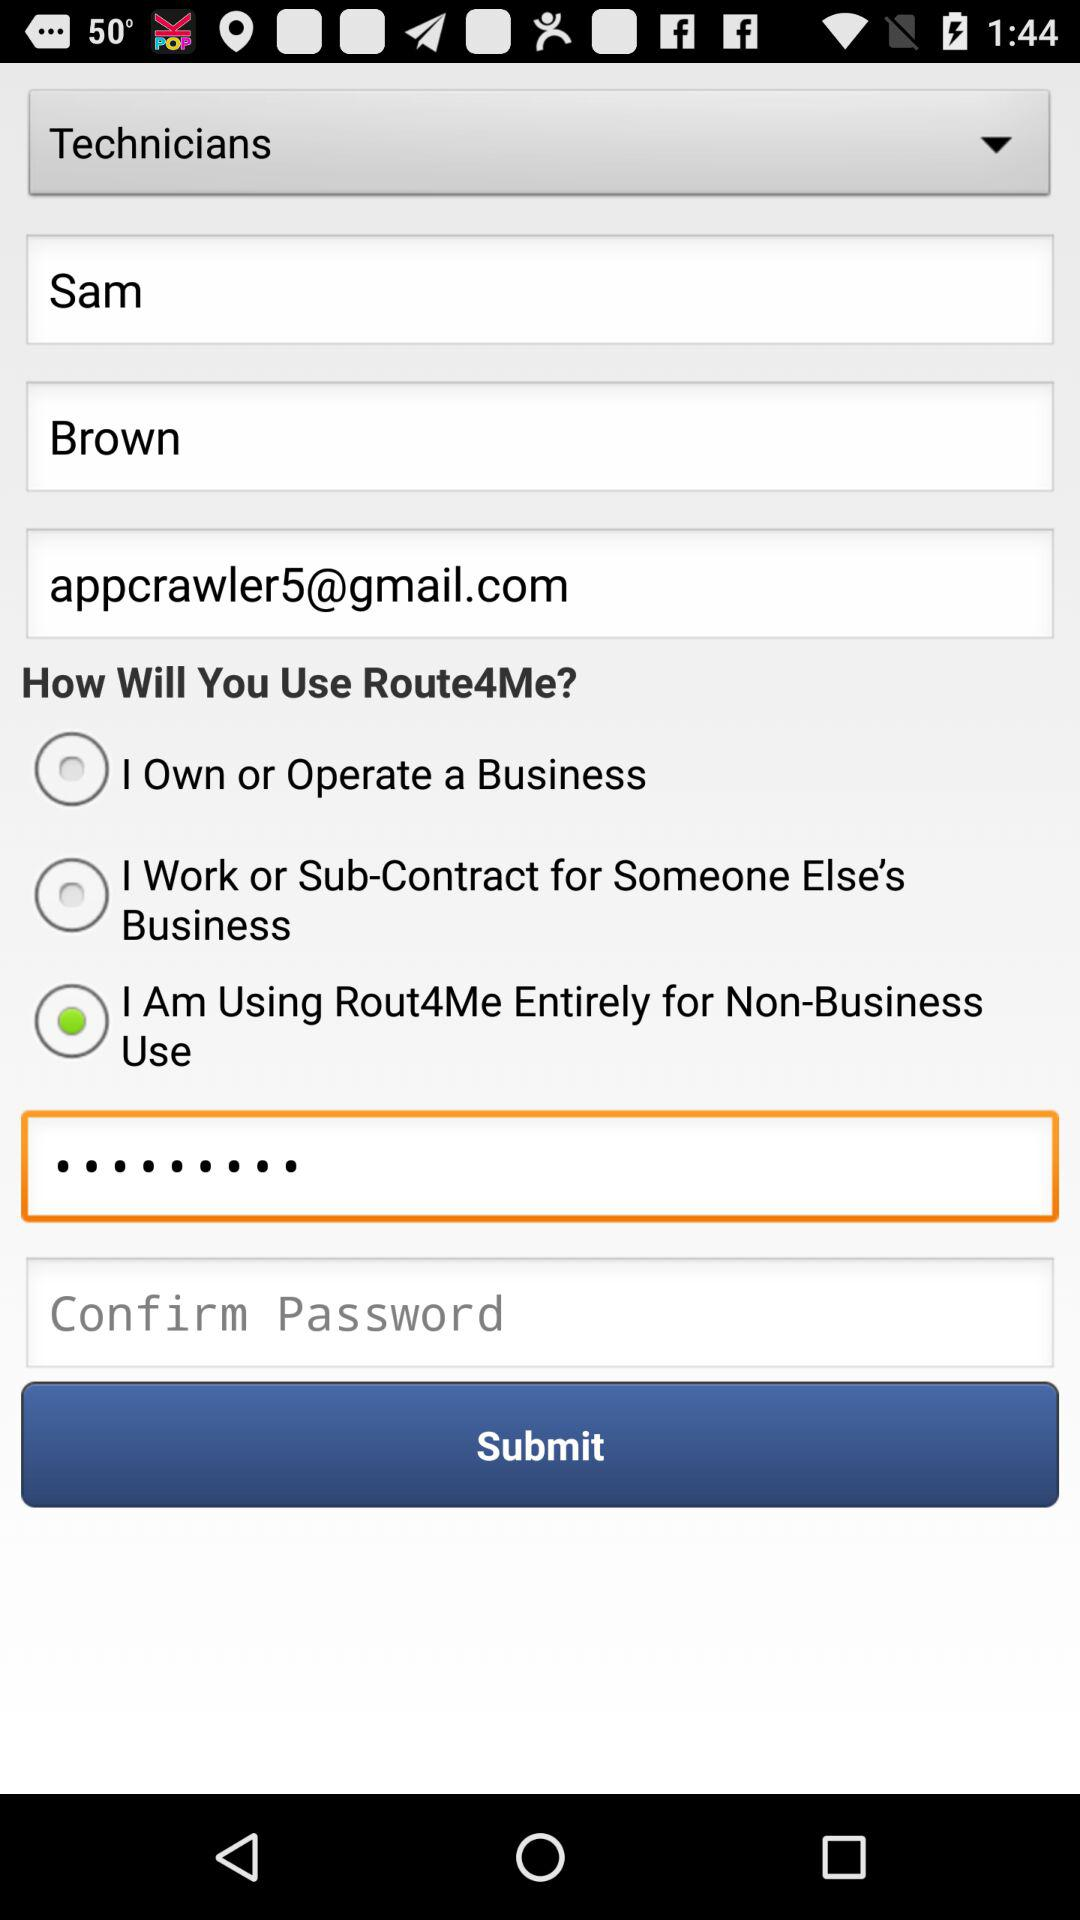How many text inputs are there for the user to enter their name?
Answer the question using a single word or phrase. 2 